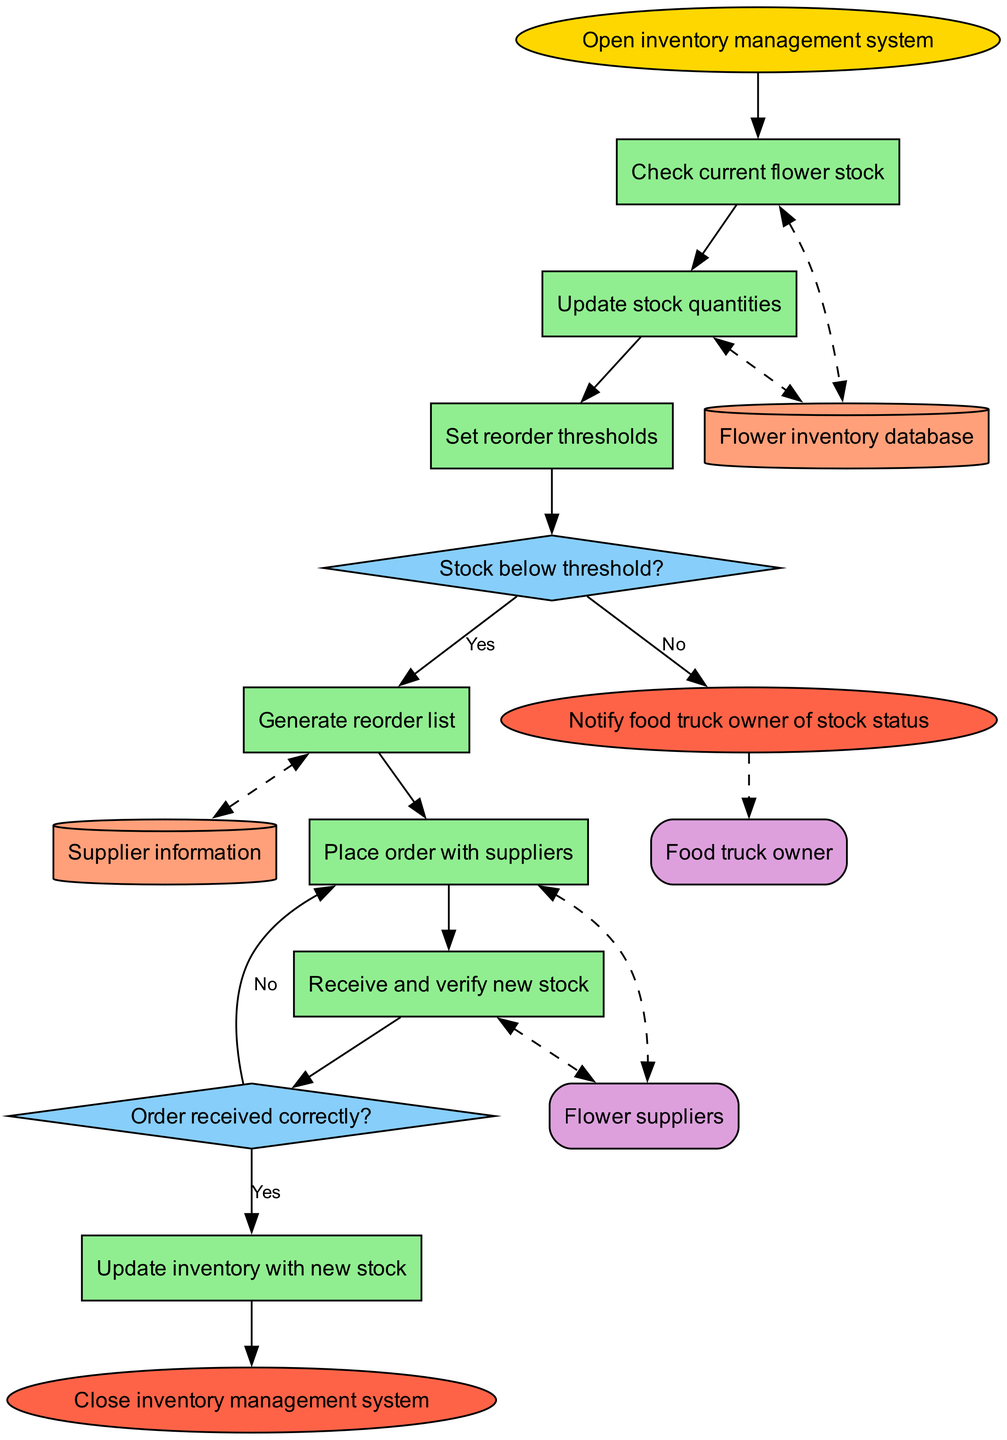What is the first process in the flowchart? The first process after starting the inventory management system is to check the current flower stock. This is the first process node connected directly after the start node.
Answer: Check current flower stock How many decision nodes are present in the diagram? The diagram features two decision nodes. One checks if the stock is below the threshold, and the second checks if the order was received correctly. Each decision node is represented as a diamond shape.
Answer: 2 What happens if the stock is below the threshold? If the stock is below the threshold, the flowchart indicates that a reorder list is generated, and the process continues towards placing an order with suppliers. The edge labeled 'Yes' from the decision node leads to this outcome.
Answer: Generate reorder list What is the final process before closing the inventory management system? The last process before closing the inventory management system is to update the inventory with new stock. This follows the decision about whether the order was received correctly.
Answer: Update inventory with new stock Which external entity is notified at the end? The food truck owner is notified of the stock status at the end of the process. This is represented at the end node, which connects to the food truck owner as an external entity.
Answer: Food truck owner What action follows the receipt and verification of new stock? After receiving and verifying the new stock, the action taken is to update the inventory with the new stock. This sequential flow ensures that the inventory reflects the latest stock available.
Answer: Update inventory with new stock What type of node represents the flower inventory database? The flower inventory database is represented as a data store node shaped like a cylinder. This visual representation is used to signify storage or database-related functionalities in the flowchart.
Answer: Cylinder What is the consequence of the order not being received correctly? If the order is not received correctly, the flowchart indicates that the order process loops back to placing the order with suppliers again. The edge labeled 'No' connects back to this action in the flow.
Answer: Place order with suppliers 